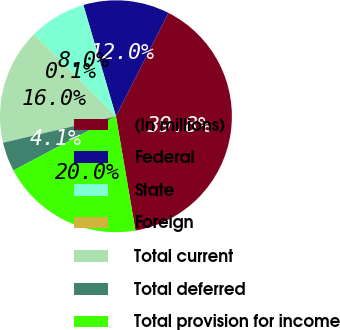Convert chart to OTSL. <chart><loc_0><loc_0><loc_500><loc_500><pie_chart><fcel>(In millions)<fcel>Federal<fcel>State<fcel>Foreign<fcel>Total current<fcel>Total deferred<fcel>Total provision for income<nl><fcel>39.82%<fcel>12.02%<fcel>8.04%<fcel>0.1%<fcel>15.99%<fcel>4.07%<fcel>19.96%<nl></chart> 